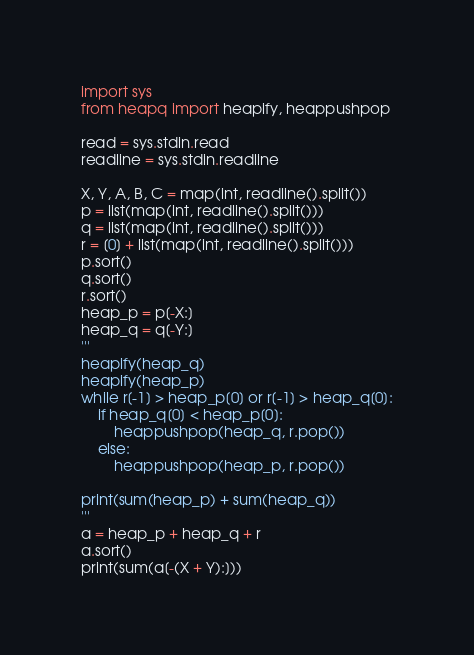Convert code to text. <code><loc_0><loc_0><loc_500><loc_500><_Python_>import sys
from heapq import heapify, heappushpop

read = sys.stdin.read
readline = sys.stdin.readline

X, Y, A, B, C = map(int, readline().split())
p = list(map(int, readline().split()))
q = list(map(int, readline().split()))
r = [0] + list(map(int, readline().split()))
p.sort()
q.sort()
r.sort()
heap_p = p[-X:]
heap_q = q[-Y:]
'''
heapify(heap_q)
heapify(heap_p)
while r[-1] > heap_p[0] or r[-1] > heap_q[0]:
    if heap_q[0] < heap_p[0]:
        heappushpop(heap_q, r.pop())
    else:
        heappushpop(heap_p, r.pop())

print(sum(heap_p) + sum(heap_q))
'''
a = heap_p + heap_q + r
a.sort()
print(sum(a[-(X + Y):]))
</code> 